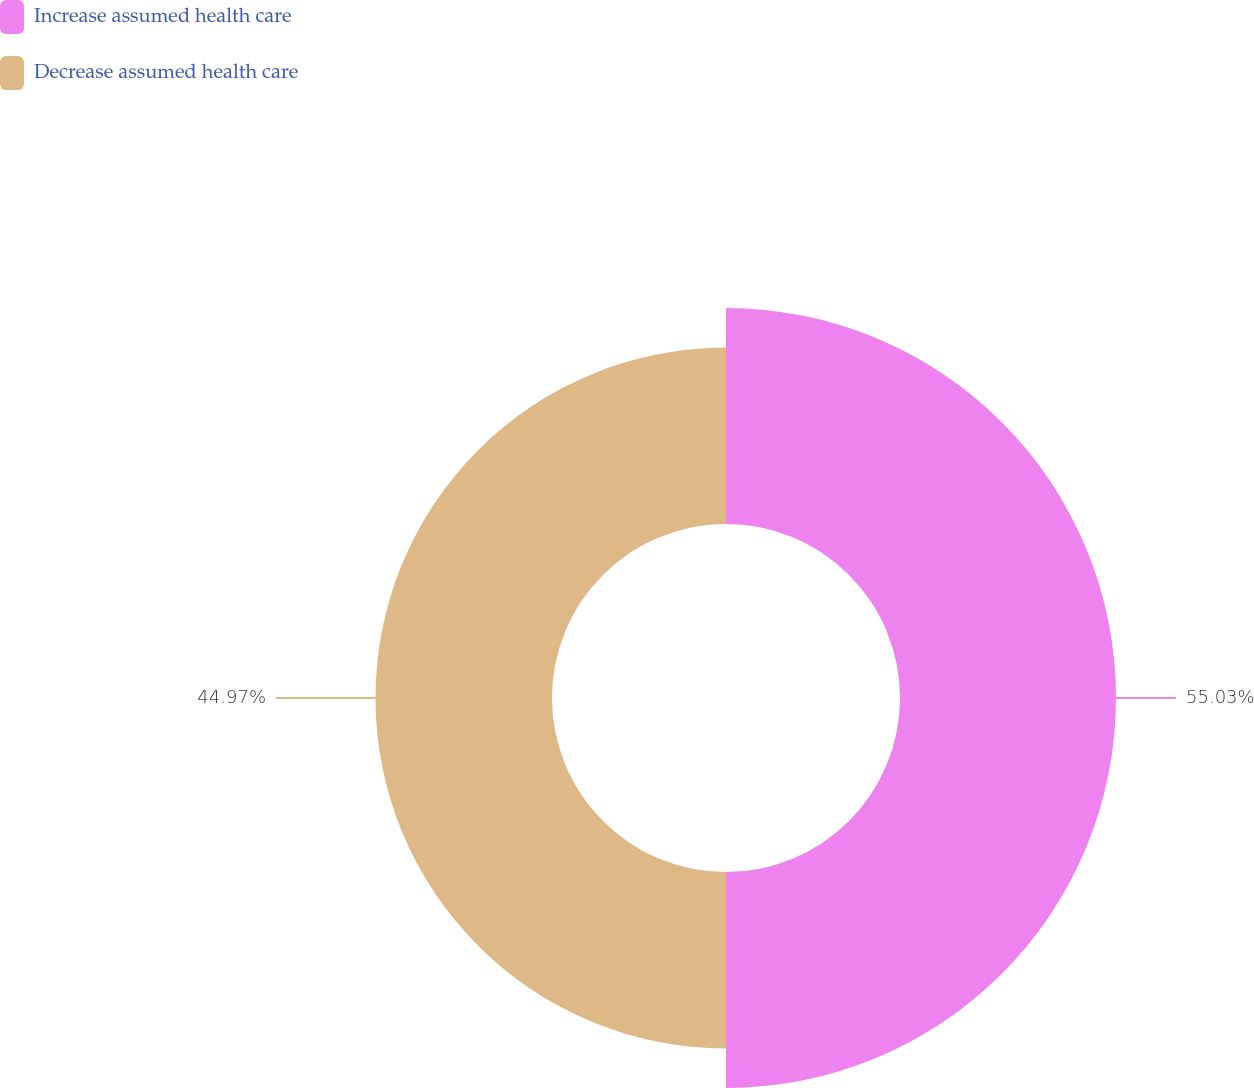Convert chart to OTSL. <chart><loc_0><loc_0><loc_500><loc_500><pie_chart><fcel>Increase assumed health care<fcel>Decrease assumed health care<nl><fcel>55.03%<fcel>44.97%<nl></chart> 